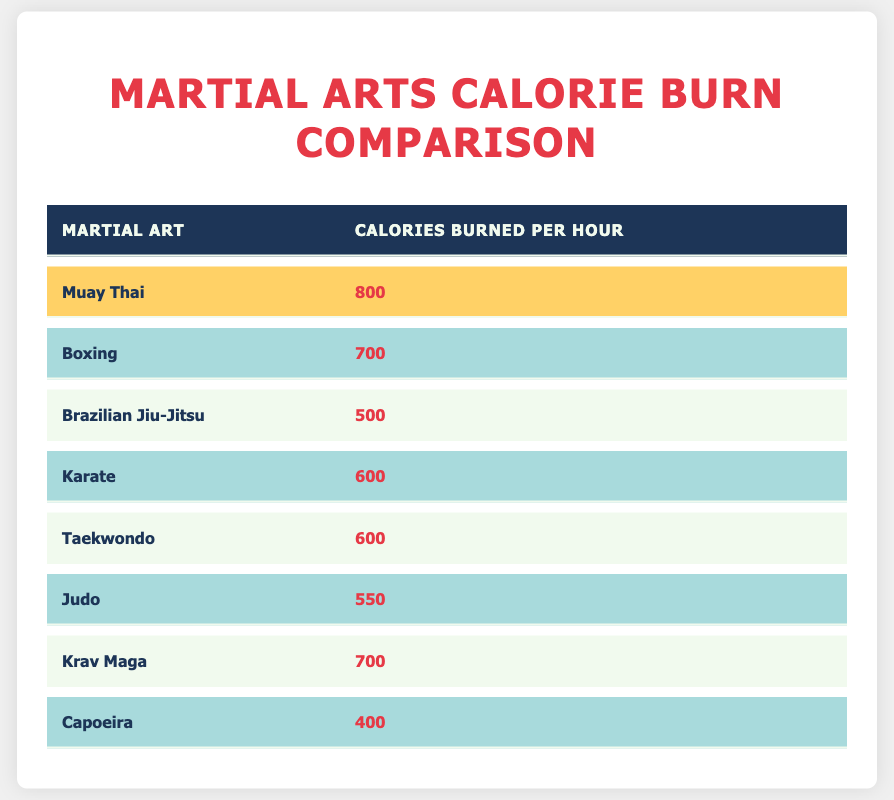What martial art burns the most calories per hour? The table highlights "Muay Thai" as the martial art that burns the most calories, with a total of 800 calories burned per hour.
Answer: Muay Thai How many calories does boxing burn per hour? According to the table, boxing burns 700 calories per hour.
Answer: 700 What is the difference in calorie burn between Muay Thai and Brazilian Jiu-Jitsu? Muay Thai burns 800 calories, while Brazilian Jiu-Jitsu burns 500 calories. The difference is calculated by subtracting 500 from 800, which equals 300.
Answer: 300 Is it true that both Taekwondo and Karate burn the same number of calories per hour? Both Taekwondo and Karate are listed in the table as burning 600 calories. Therefore, it is true that they have the same calorie burn per hour.
Answer: Yes What is the average calorie burn for all the martial arts listed? To find the average, sum all the calories burned (800 + 700 + 500 + 600 + 600 + 550 + 700 + 400 = 4550) and divide by the number of martial arts (8). So, 4550 / 8 equals 568.75, which can be rounded to 569.
Answer: 569 Which martial arts are tied for burning the least calories per hour? The table indicates that "Capoeira" is the martial art that burns the least calories, at 400 calories. No other martial arts have a calorie burn equal to this, so "Capoeira" stands alone.
Answer: Capoeira How many martial arts burn fewer calories than Muay Thai? The table lists a total of 8 martial arts. Comparatively, 6 martial arts (Boxing, Brazilian Jiu-Jitsu, Karate, Taekwondo, Judo, and Capoeira) burn fewer calories than Muay Thai, which burns 800 calories per hour.
Answer: 6 What percentage of calories burned by Muay Thai is more than those burned by Capoeira? Muay Thai burns 800 calories, while Capoeira burns 400. The difference is 800 - 400 = 400. To find the percentage, divide the difference by the calories burned by Capoeira: (400 / 400) * 100 = 100%.
Answer: 100% 